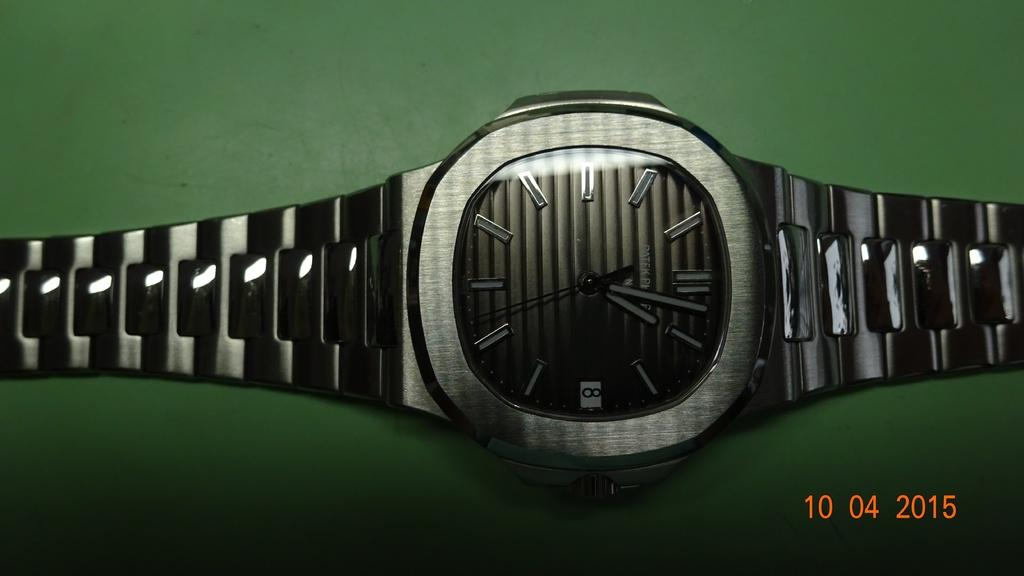<image>
Give a short and clear explanation of the subsequent image. A picture of a watch that was taken on 10/04/2015. 